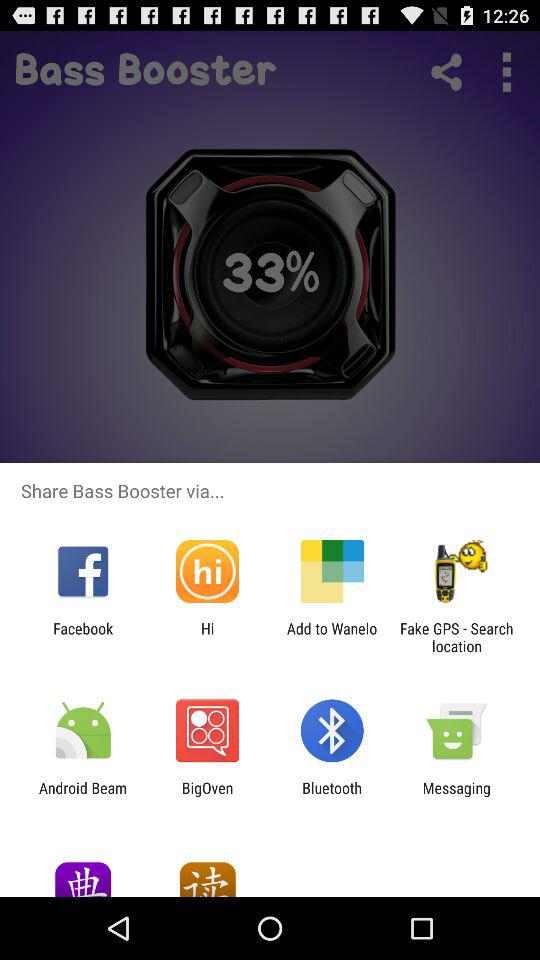What is the app name? The app name is "Bass Booster". 